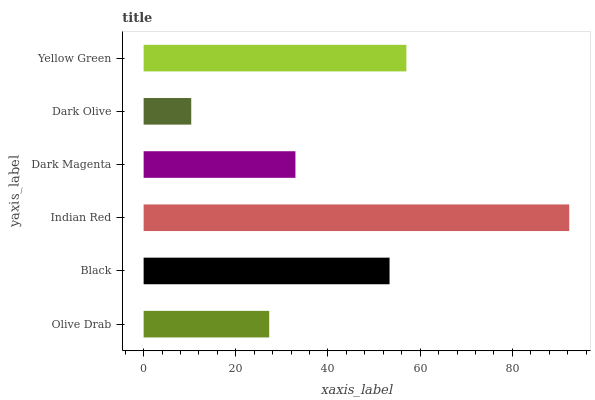Is Dark Olive the minimum?
Answer yes or no. Yes. Is Indian Red the maximum?
Answer yes or no. Yes. Is Black the minimum?
Answer yes or no. No. Is Black the maximum?
Answer yes or no. No. Is Black greater than Olive Drab?
Answer yes or no. Yes. Is Olive Drab less than Black?
Answer yes or no. Yes. Is Olive Drab greater than Black?
Answer yes or no. No. Is Black less than Olive Drab?
Answer yes or no. No. Is Black the high median?
Answer yes or no. Yes. Is Dark Magenta the low median?
Answer yes or no. Yes. Is Indian Red the high median?
Answer yes or no. No. Is Dark Olive the low median?
Answer yes or no. No. 